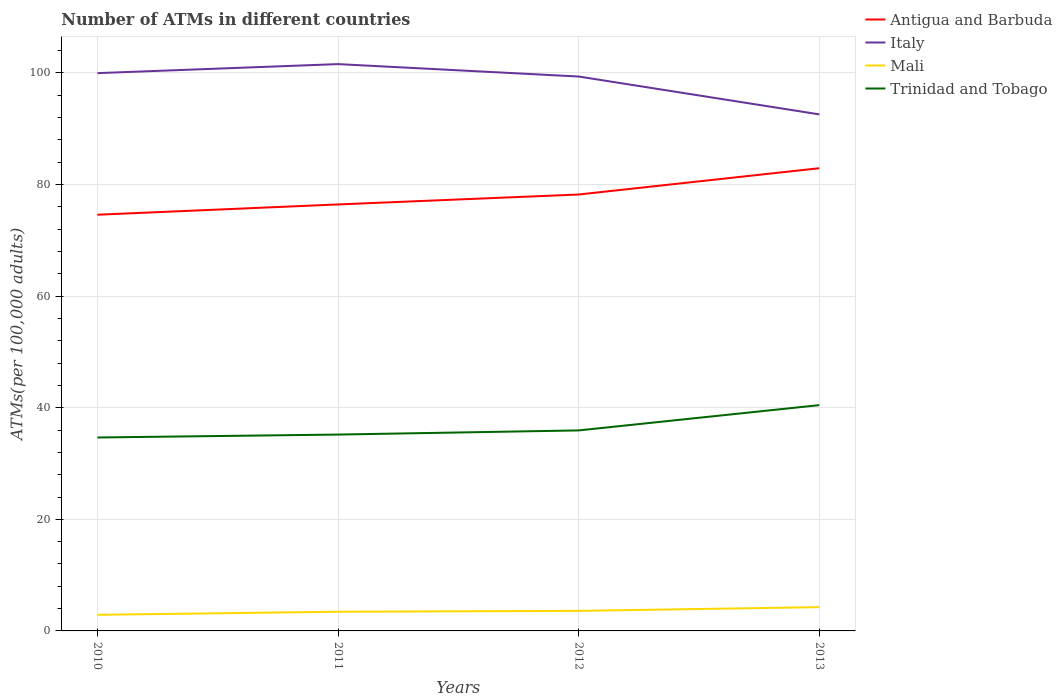How many different coloured lines are there?
Your answer should be very brief. 4. Does the line corresponding to Italy intersect with the line corresponding to Mali?
Give a very brief answer. No. Is the number of lines equal to the number of legend labels?
Your answer should be compact. Yes. Across all years, what is the maximum number of ATMs in Italy?
Keep it short and to the point. 92.57. What is the total number of ATMs in Antigua and Barbuda in the graph?
Your answer should be compact. -1.84. What is the difference between the highest and the second highest number of ATMs in Trinidad and Tobago?
Give a very brief answer. 5.8. Are the values on the major ticks of Y-axis written in scientific E-notation?
Offer a terse response. No. How many legend labels are there?
Provide a succinct answer. 4. How are the legend labels stacked?
Keep it short and to the point. Vertical. What is the title of the graph?
Provide a short and direct response. Number of ATMs in different countries. What is the label or title of the X-axis?
Ensure brevity in your answer.  Years. What is the label or title of the Y-axis?
Provide a succinct answer. ATMs(per 100,0 adults). What is the ATMs(per 100,000 adults) of Antigua and Barbuda in 2010?
Your answer should be very brief. 74.59. What is the ATMs(per 100,000 adults) of Italy in 2010?
Your answer should be compact. 99.97. What is the ATMs(per 100,000 adults) in Mali in 2010?
Make the answer very short. 2.89. What is the ATMs(per 100,000 adults) of Trinidad and Tobago in 2010?
Your answer should be very brief. 34.67. What is the ATMs(per 100,000 adults) in Antigua and Barbuda in 2011?
Your answer should be very brief. 76.44. What is the ATMs(per 100,000 adults) in Italy in 2011?
Give a very brief answer. 101.58. What is the ATMs(per 100,000 adults) of Mali in 2011?
Offer a terse response. 3.44. What is the ATMs(per 100,000 adults) of Trinidad and Tobago in 2011?
Keep it short and to the point. 35.19. What is the ATMs(per 100,000 adults) in Antigua and Barbuda in 2012?
Provide a succinct answer. 78.21. What is the ATMs(per 100,000 adults) of Italy in 2012?
Your response must be concise. 99.36. What is the ATMs(per 100,000 adults) in Mali in 2012?
Ensure brevity in your answer.  3.59. What is the ATMs(per 100,000 adults) in Trinidad and Tobago in 2012?
Ensure brevity in your answer.  35.94. What is the ATMs(per 100,000 adults) in Antigua and Barbuda in 2013?
Offer a very short reply. 82.92. What is the ATMs(per 100,000 adults) of Italy in 2013?
Your answer should be compact. 92.57. What is the ATMs(per 100,000 adults) in Mali in 2013?
Ensure brevity in your answer.  4.26. What is the ATMs(per 100,000 adults) in Trinidad and Tobago in 2013?
Your answer should be very brief. 40.47. Across all years, what is the maximum ATMs(per 100,000 adults) in Antigua and Barbuda?
Your answer should be compact. 82.92. Across all years, what is the maximum ATMs(per 100,000 adults) in Italy?
Your answer should be compact. 101.58. Across all years, what is the maximum ATMs(per 100,000 adults) in Mali?
Keep it short and to the point. 4.26. Across all years, what is the maximum ATMs(per 100,000 adults) of Trinidad and Tobago?
Provide a short and direct response. 40.47. Across all years, what is the minimum ATMs(per 100,000 adults) in Antigua and Barbuda?
Offer a very short reply. 74.59. Across all years, what is the minimum ATMs(per 100,000 adults) in Italy?
Ensure brevity in your answer.  92.57. Across all years, what is the minimum ATMs(per 100,000 adults) of Mali?
Keep it short and to the point. 2.89. Across all years, what is the minimum ATMs(per 100,000 adults) of Trinidad and Tobago?
Offer a very short reply. 34.67. What is the total ATMs(per 100,000 adults) of Antigua and Barbuda in the graph?
Provide a short and direct response. 312.17. What is the total ATMs(per 100,000 adults) in Italy in the graph?
Offer a very short reply. 393.49. What is the total ATMs(per 100,000 adults) of Mali in the graph?
Ensure brevity in your answer.  14.18. What is the total ATMs(per 100,000 adults) in Trinidad and Tobago in the graph?
Give a very brief answer. 146.26. What is the difference between the ATMs(per 100,000 adults) in Antigua and Barbuda in 2010 and that in 2011?
Your answer should be compact. -1.84. What is the difference between the ATMs(per 100,000 adults) in Italy in 2010 and that in 2011?
Provide a succinct answer. -1.62. What is the difference between the ATMs(per 100,000 adults) of Mali in 2010 and that in 2011?
Your response must be concise. -0.55. What is the difference between the ATMs(per 100,000 adults) in Trinidad and Tobago in 2010 and that in 2011?
Ensure brevity in your answer.  -0.52. What is the difference between the ATMs(per 100,000 adults) in Antigua and Barbuda in 2010 and that in 2012?
Your response must be concise. -3.62. What is the difference between the ATMs(per 100,000 adults) of Italy in 2010 and that in 2012?
Keep it short and to the point. 0.61. What is the difference between the ATMs(per 100,000 adults) of Mali in 2010 and that in 2012?
Offer a very short reply. -0.7. What is the difference between the ATMs(per 100,000 adults) of Trinidad and Tobago in 2010 and that in 2012?
Provide a succinct answer. -1.27. What is the difference between the ATMs(per 100,000 adults) of Antigua and Barbuda in 2010 and that in 2013?
Offer a terse response. -8.33. What is the difference between the ATMs(per 100,000 adults) in Italy in 2010 and that in 2013?
Offer a terse response. 7.39. What is the difference between the ATMs(per 100,000 adults) of Mali in 2010 and that in 2013?
Ensure brevity in your answer.  -1.37. What is the difference between the ATMs(per 100,000 adults) in Trinidad and Tobago in 2010 and that in 2013?
Provide a succinct answer. -5.8. What is the difference between the ATMs(per 100,000 adults) in Antigua and Barbuda in 2011 and that in 2012?
Provide a succinct answer. -1.78. What is the difference between the ATMs(per 100,000 adults) of Italy in 2011 and that in 2012?
Ensure brevity in your answer.  2.23. What is the difference between the ATMs(per 100,000 adults) in Mali in 2011 and that in 2012?
Give a very brief answer. -0.15. What is the difference between the ATMs(per 100,000 adults) of Trinidad and Tobago in 2011 and that in 2012?
Give a very brief answer. -0.75. What is the difference between the ATMs(per 100,000 adults) in Antigua and Barbuda in 2011 and that in 2013?
Your response must be concise. -6.49. What is the difference between the ATMs(per 100,000 adults) of Italy in 2011 and that in 2013?
Provide a succinct answer. 9.01. What is the difference between the ATMs(per 100,000 adults) of Mali in 2011 and that in 2013?
Your answer should be compact. -0.82. What is the difference between the ATMs(per 100,000 adults) of Trinidad and Tobago in 2011 and that in 2013?
Provide a succinct answer. -5.28. What is the difference between the ATMs(per 100,000 adults) in Antigua and Barbuda in 2012 and that in 2013?
Keep it short and to the point. -4.71. What is the difference between the ATMs(per 100,000 adults) in Italy in 2012 and that in 2013?
Offer a terse response. 6.79. What is the difference between the ATMs(per 100,000 adults) of Mali in 2012 and that in 2013?
Your answer should be very brief. -0.67. What is the difference between the ATMs(per 100,000 adults) of Trinidad and Tobago in 2012 and that in 2013?
Ensure brevity in your answer.  -4.53. What is the difference between the ATMs(per 100,000 adults) of Antigua and Barbuda in 2010 and the ATMs(per 100,000 adults) of Italy in 2011?
Provide a succinct answer. -26.99. What is the difference between the ATMs(per 100,000 adults) of Antigua and Barbuda in 2010 and the ATMs(per 100,000 adults) of Mali in 2011?
Keep it short and to the point. 71.15. What is the difference between the ATMs(per 100,000 adults) in Antigua and Barbuda in 2010 and the ATMs(per 100,000 adults) in Trinidad and Tobago in 2011?
Your answer should be very brief. 39.4. What is the difference between the ATMs(per 100,000 adults) of Italy in 2010 and the ATMs(per 100,000 adults) of Mali in 2011?
Offer a very short reply. 96.53. What is the difference between the ATMs(per 100,000 adults) of Italy in 2010 and the ATMs(per 100,000 adults) of Trinidad and Tobago in 2011?
Offer a terse response. 64.78. What is the difference between the ATMs(per 100,000 adults) of Mali in 2010 and the ATMs(per 100,000 adults) of Trinidad and Tobago in 2011?
Offer a very short reply. -32.3. What is the difference between the ATMs(per 100,000 adults) of Antigua and Barbuda in 2010 and the ATMs(per 100,000 adults) of Italy in 2012?
Keep it short and to the point. -24.77. What is the difference between the ATMs(per 100,000 adults) of Antigua and Barbuda in 2010 and the ATMs(per 100,000 adults) of Mali in 2012?
Offer a terse response. 71. What is the difference between the ATMs(per 100,000 adults) in Antigua and Barbuda in 2010 and the ATMs(per 100,000 adults) in Trinidad and Tobago in 2012?
Make the answer very short. 38.66. What is the difference between the ATMs(per 100,000 adults) of Italy in 2010 and the ATMs(per 100,000 adults) of Mali in 2012?
Make the answer very short. 96.38. What is the difference between the ATMs(per 100,000 adults) in Italy in 2010 and the ATMs(per 100,000 adults) in Trinidad and Tobago in 2012?
Ensure brevity in your answer.  64.03. What is the difference between the ATMs(per 100,000 adults) of Mali in 2010 and the ATMs(per 100,000 adults) of Trinidad and Tobago in 2012?
Provide a succinct answer. -33.05. What is the difference between the ATMs(per 100,000 adults) of Antigua and Barbuda in 2010 and the ATMs(per 100,000 adults) of Italy in 2013?
Your answer should be very brief. -17.98. What is the difference between the ATMs(per 100,000 adults) of Antigua and Barbuda in 2010 and the ATMs(per 100,000 adults) of Mali in 2013?
Offer a very short reply. 70.33. What is the difference between the ATMs(per 100,000 adults) in Antigua and Barbuda in 2010 and the ATMs(per 100,000 adults) in Trinidad and Tobago in 2013?
Your response must be concise. 34.13. What is the difference between the ATMs(per 100,000 adults) in Italy in 2010 and the ATMs(per 100,000 adults) in Mali in 2013?
Offer a very short reply. 95.71. What is the difference between the ATMs(per 100,000 adults) of Italy in 2010 and the ATMs(per 100,000 adults) of Trinidad and Tobago in 2013?
Provide a succinct answer. 59.5. What is the difference between the ATMs(per 100,000 adults) in Mali in 2010 and the ATMs(per 100,000 adults) in Trinidad and Tobago in 2013?
Make the answer very short. -37.58. What is the difference between the ATMs(per 100,000 adults) of Antigua and Barbuda in 2011 and the ATMs(per 100,000 adults) of Italy in 2012?
Provide a short and direct response. -22.92. What is the difference between the ATMs(per 100,000 adults) in Antigua and Barbuda in 2011 and the ATMs(per 100,000 adults) in Mali in 2012?
Provide a short and direct response. 72.84. What is the difference between the ATMs(per 100,000 adults) in Antigua and Barbuda in 2011 and the ATMs(per 100,000 adults) in Trinidad and Tobago in 2012?
Offer a terse response. 40.5. What is the difference between the ATMs(per 100,000 adults) in Italy in 2011 and the ATMs(per 100,000 adults) in Mali in 2012?
Offer a terse response. 97.99. What is the difference between the ATMs(per 100,000 adults) in Italy in 2011 and the ATMs(per 100,000 adults) in Trinidad and Tobago in 2012?
Keep it short and to the point. 65.65. What is the difference between the ATMs(per 100,000 adults) of Mali in 2011 and the ATMs(per 100,000 adults) of Trinidad and Tobago in 2012?
Provide a succinct answer. -32.5. What is the difference between the ATMs(per 100,000 adults) in Antigua and Barbuda in 2011 and the ATMs(per 100,000 adults) in Italy in 2013?
Your answer should be compact. -16.14. What is the difference between the ATMs(per 100,000 adults) of Antigua and Barbuda in 2011 and the ATMs(per 100,000 adults) of Mali in 2013?
Your response must be concise. 72.17. What is the difference between the ATMs(per 100,000 adults) of Antigua and Barbuda in 2011 and the ATMs(per 100,000 adults) of Trinidad and Tobago in 2013?
Keep it short and to the point. 35.97. What is the difference between the ATMs(per 100,000 adults) of Italy in 2011 and the ATMs(per 100,000 adults) of Mali in 2013?
Make the answer very short. 97.32. What is the difference between the ATMs(per 100,000 adults) in Italy in 2011 and the ATMs(per 100,000 adults) in Trinidad and Tobago in 2013?
Provide a short and direct response. 61.12. What is the difference between the ATMs(per 100,000 adults) of Mali in 2011 and the ATMs(per 100,000 adults) of Trinidad and Tobago in 2013?
Your answer should be very brief. -37.03. What is the difference between the ATMs(per 100,000 adults) in Antigua and Barbuda in 2012 and the ATMs(per 100,000 adults) in Italy in 2013?
Offer a very short reply. -14.36. What is the difference between the ATMs(per 100,000 adults) of Antigua and Barbuda in 2012 and the ATMs(per 100,000 adults) of Mali in 2013?
Provide a succinct answer. 73.95. What is the difference between the ATMs(per 100,000 adults) of Antigua and Barbuda in 2012 and the ATMs(per 100,000 adults) of Trinidad and Tobago in 2013?
Provide a short and direct response. 37.75. What is the difference between the ATMs(per 100,000 adults) in Italy in 2012 and the ATMs(per 100,000 adults) in Mali in 2013?
Offer a terse response. 95.1. What is the difference between the ATMs(per 100,000 adults) in Italy in 2012 and the ATMs(per 100,000 adults) in Trinidad and Tobago in 2013?
Keep it short and to the point. 58.89. What is the difference between the ATMs(per 100,000 adults) in Mali in 2012 and the ATMs(per 100,000 adults) in Trinidad and Tobago in 2013?
Keep it short and to the point. -36.88. What is the average ATMs(per 100,000 adults) in Antigua and Barbuda per year?
Keep it short and to the point. 78.04. What is the average ATMs(per 100,000 adults) of Italy per year?
Offer a very short reply. 98.37. What is the average ATMs(per 100,000 adults) of Mali per year?
Provide a succinct answer. 3.55. What is the average ATMs(per 100,000 adults) of Trinidad and Tobago per year?
Offer a terse response. 36.57. In the year 2010, what is the difference between the ATMs(per 100,000 adults) in Antigua and Barbuda and ATMs(per 100,000 adults) in Italy?
Offer a very short reply. -25.38. In the year 2010, what is the difference between the ATMs(per 100,000 adults) in Antigua and Barbuda and ATMs(per 100,000 adults) in Mali?
Offer a very short reply. 71.7. In the year 2010, what is the difference between the ATMs(per 100,000 adults) in Antigua and Barbuda and ATMs(per 100,000 adults) in Trinidad and Tobago?
Give a very brief answer. 39.93. In the year 2010, what is the difference between the ATMs(per 100,000 adults) of Italy and ATMs(per 100,000 adults) of Mali?
Keep it short and to the point. 97.08. In the year 2010, what is the difference between the ATMs(per 100,000 adults) in Italy and ATMs(per 100,000 adults) in Trinidad and Tobago?
Offer a terse response. 65.3. In the year 2010, what is the difference between the ATMs(per 100,000 adults) in Mali and ATMs(per 100,000 adults) in Trinidad and Tobago?
Offer a terse response. -31.78. In the year 2011, what is the difference between the ATMs(per 100,000 adults) in Antigua and Barbuda and ATMs(per 100,000 adults) in Italy?
Your answer should be very brief. -25.15. In the year 2011, what is the difference between the ATMs(per 100,000 adults) in Antigua and Barbuda and ATMs(per 100,000 adults) in Mali?
Provide a short and direct response. 73. In the year 2011, what is the difference between the ATMs(per 100,000 adults) in Antigua and Barbuda and ATMs(per 100,000 adults) in Trinidad and Tobago?
Provide a succinct answer. 41.24. In the year 2011, what is the difference between the ATMs(per 100,000 adults) in Italy and ATMs(per 100,000 adults) in Mali?
Your response must be concise. 98.14. In the year 2011, what is the difference between the ATMs(per 100,000 adults) in Italy and ATMs(per 100,000 adults) in Trinidad and Tobago?
Provide a succinct answer. 66.39. In the year 2011, what is the difference between the ATMs(per 100,000 adults) of Mali and ATMs(per 100,000 adults) of Trinidad and Tobago?
Offer a very short reply. -31.75. In the year 2012, what is the difference between the ATMs(per 100,000 adults) of Antigua and Barbuda and ATMs(per 100,000 adults) of Italy?
Provide a short and direct response. -21.15. In the year 2012, what is the difference between the ATMs(per 100,000 adults) of Antigua and Barbuda and ATMs(per 100,000 adults) of Mali?
Give a very brief answer. 74.62. In the year 2012, what is the difference between the ATMs(per 100,000 adults) in Antigua and Barbuda and ATMs(per 100,000 adults) in Trinidad and Tobago?
Offer a terse response. 42.28. In the year 2012, what is the difference between the ATMs(per 100,000 adults) of Italy and ATMs(per 100,000 adults) of Mali?
Offer a terse response. 95.77. In the year 2012, what is the difference between the ATMs(per 100,000 adults) in Italy and ATMs(per 100,000 adults) in Trinidad and Tobago?
Provide a succinct answer. 63.42. In the year 2012, what is the difference between the ATMs(per 100,000 adults) of Mali and ATMs(per 100,000 adults) of Trinidad and Tobago?
Offer a terse response. -32.35. In the year 2013, what is the difference between the ATMs(per 100,000 adults) in Antigua and Barbuda and ATMs(per 100,000 adults) in Italy?
Offer a very short reply. -9.65. In the year 2013, what is the difference between the ATMs(per 100,000 adults) in Antigua and Barbuda and ATMs(per 100,000 adults) in Mali?
Provide a short and direct response. 78.66. In the year 2013, what is the difference between the ATMs(per 100,000 adults) in Antigua and Barbuda and ATMs(per 100,000 adults) in Trinidad and Tobago?
Provide a succinct answer. 42.46. In the year 2013, what is the difference between the ATMs(per 100,000 adults) of Italy and ATMs(per 100,000 adults) of Mali?
Your response must be concise. 88.31. In the year 2013, what is the difference between the ATMs(per 100,000 adults) of Italy and ATMs(per 100,000 adults) of Trinidad and Tobago?
Your answer should be very brief. 52.11. In the year 2013, what is the difference between the ATMs(per 100,000 adults) of Mali and ATMs(per 100,000 adults) of Trinidad and Tobago?
Your answer should be very brief. -36.21. What is the ratio of the ATMs(per 100,000 adults) in Antigua and Barbuda in 2010 to that in 2011?
Offer a terse response. 0.98. What is the ratio of the ATMs(per 100,000 adults) of Italy in 2010 to that in 2011?
Ensure brevity in your answer.  0.98. What is the ratio of the ATMs(per 100,000 adults) in Mali in 2010 to that in 2011?
Provide a succinct answer. 0.84. What is the ratio of the ATMs(per 100,000 adults) of Trinidad and Tobago in 2010 to that in 2011?
Keep it short and to the point. 0.99. What is the ratio of the ATMs(per 100,000 adults) in Antigua and Barbuda in 2010 to that in 2012?
Offer a very short reply. 0.95. What is the ratio of the ATMs(per 100,000 adults) in Italy in 2010 to that in 2012?
Your response must be concise. 1.01. What is the ratio of the ATMs(per 100,000 adults) of Mali in 2010 to that in 2012?
Make the answer very short. 0.8. What is the ratio of the ATMs(per 100,000 adults) of Trinidad and Tobago in 2010 to that in 2012?
Your response must be concise. 0.96. What is the ratio of the ATMs(per 100,000 adults) of Antigua and Barbuda in 2010 to that in 2013?
Your response must be concise. 0.9. What is the ratio of the ATMs(per 100,000 adults) in Italy in 2010 to that in 2013?
Ensure brevity in your answer.  1.08. What is the ratio of the ATMs(per 100,000 adults) of Mali in 2010 to that in 2013?
Provide a succinct answer. 0.68. What is the ratio of the ATMs(per 100,000 adults) of Trinidad and Tobago in 2010 to that in 2013?
Provide a short and direct response. 0.86. What is the ratio of the ATMs(per 100,000 adults) in Antigua and Barbuda in 2011 to that in 2012?
Keep it short and to the point. 0.98. What is the ratio of the ATMs(per 100,000 adults) of Italy in 2011 to that in 2012?
Offer a terse response. 1.02. What is the ratio of the ATMs(per 100,000 adults) in Mali in 2011 to that in 2012?
Give a very brief answer. 0.96. What is the ratio of the ATMs(per 100,000 adults) in Trinidad and Tobago in 2011 to that in 2012?
Provide a short and direct response. 0.98. What is the ratio of the ATMs(per 100,000 adults) in Antigua and Barbuda in 2011 to that in 2013?
Offer a very short reply. 0.92. What is the ratio of the ATMs(per 100,000 adults) of Italy in 2011 to that in 2013?
Keep it short and to the point. 1.1. What is the ratio of the ATMs(per 100,000 adults) of Mali in 2011 to that in 2013?
Provide a succinct answer. 0.81. What is the ratio of the ATMs(per 100,000 adults) of Trinidad and Tobago in 2011 to that in 2013?
Make the answer very short. 0.87. What is the ratio of the ATMs(per 100,000 adults) in Antigua and Barbuda in 2012 to that in 2013?
Your response must be concise. 0.94. What is the ratio of the ATMs(per 100,000 adults) in Italy in 2012 to that in 2013?
Provide a succinct answer. 1.07. What is the ratio of the ATMs(per 100,000 adults) of Mali in 2012 to that in 2013?
Keep it short and to the point. 0.84. What is the ratio of the ATMs(per 100,000 adults) of Trinidad and Tobago in 2012 to that in 2013?
Your answer should be compact. 0.89. What is the difference between the highest and the second highest ATMs(per 100,000 adults) in Antigua and Barbuda?
Your response must be concise. 4.71. What is the difference between the highest and the second highest ATMs(per 100,000 adults) in Italy?
Offer a very short reply. 1.62. What is the difference between the highest and the second highest ATMs(per 100,000 adults) of Mali?
Provide a short and direct response. 0.67. What is the difference between the highest and the second highest ATMs(per 100,000 adults) in Trinidad and Tobago?
Give a very brief answer. 4.53. What is the difference between the highest and the lowest ATMs(per 100,000 adults) of Antigua and Barbuda?
Provide a succinct answer. 8.33. What is the difference between the highest and the lowest ATMs(per 100,000 adults) of Italy?
Keep it short and to the point. 9.01. What is the difference between the highest and the lowest ATMs(per 100,000 adults) in Mali?
Provide a short and direct response. 1.37. What is the difference between the highest and the lowest ATMs(per 100,000 adults) of Trinidad and Tobago?
Your answer should be compact. 5.8. 